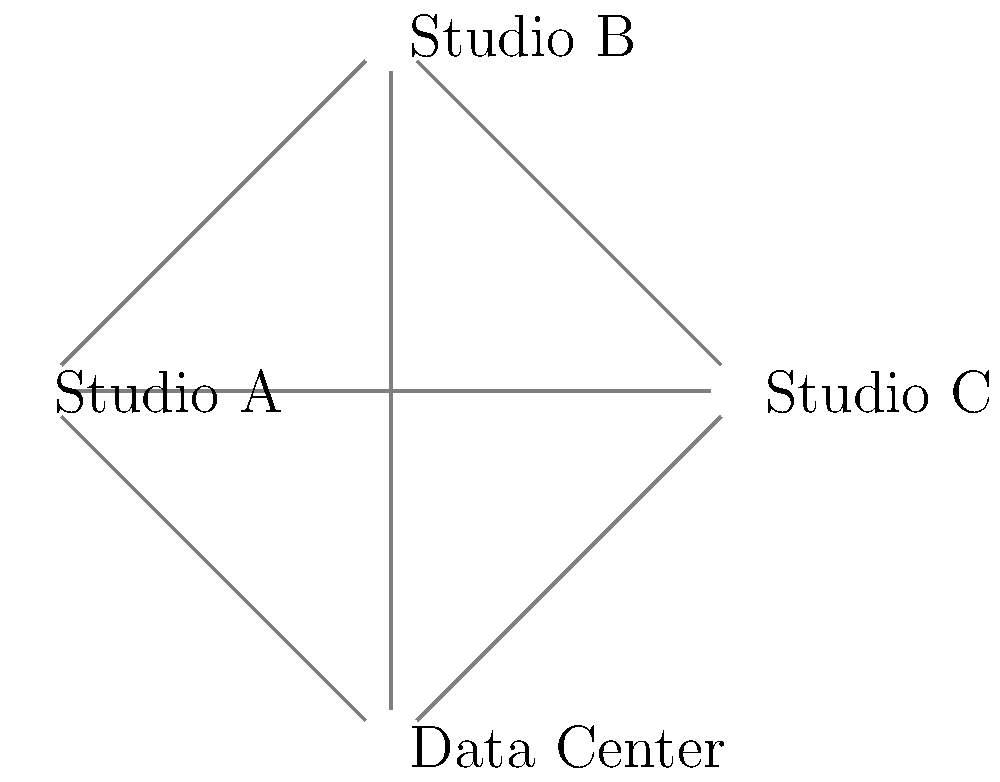As a singer-songwriter, you're expanding your recording business to multiple locations. Given the network diagram showing three recording studios (A, B, and C) and a central data center, how many connections need to fail before any studio becomes isolated from the network, assuming each connection is bi-directional? To determine how many connections need to fail before a studio becomes isolated, we need to analyze the network topology:

1. Each studio is connected to every other studio and the data center, forming a complete graph (also known as a fully connected mesh topology).

2. For Studio A:
   - Connected directly to Studio B, Studio C, and the Data Center
   - 3 direct connections

3. For Studio B:
   - Connected directly to Studio A, Studio C, and the Data Center
   - 3 direct connections

4. For Studio C:
   - Connected directly to Studio A, Studio B, and the Data Center
   - 3 direct connections

5. To isolate any studio, all 3 of its direct connections must fail.

6. The network is fault-tolerant because even if 2 connections fail for any studio, it can still reach the other nodes through the remaining connection and then through the other nodes' connections.

7. The minimum number of connection failures that could isolate a studio is 3, which would happen if all 3 connections to a single studio failed simultaneously.

Therefore, 3 connections need to fail before any studio becomes isolated from the network.
Answer: 3 connections 